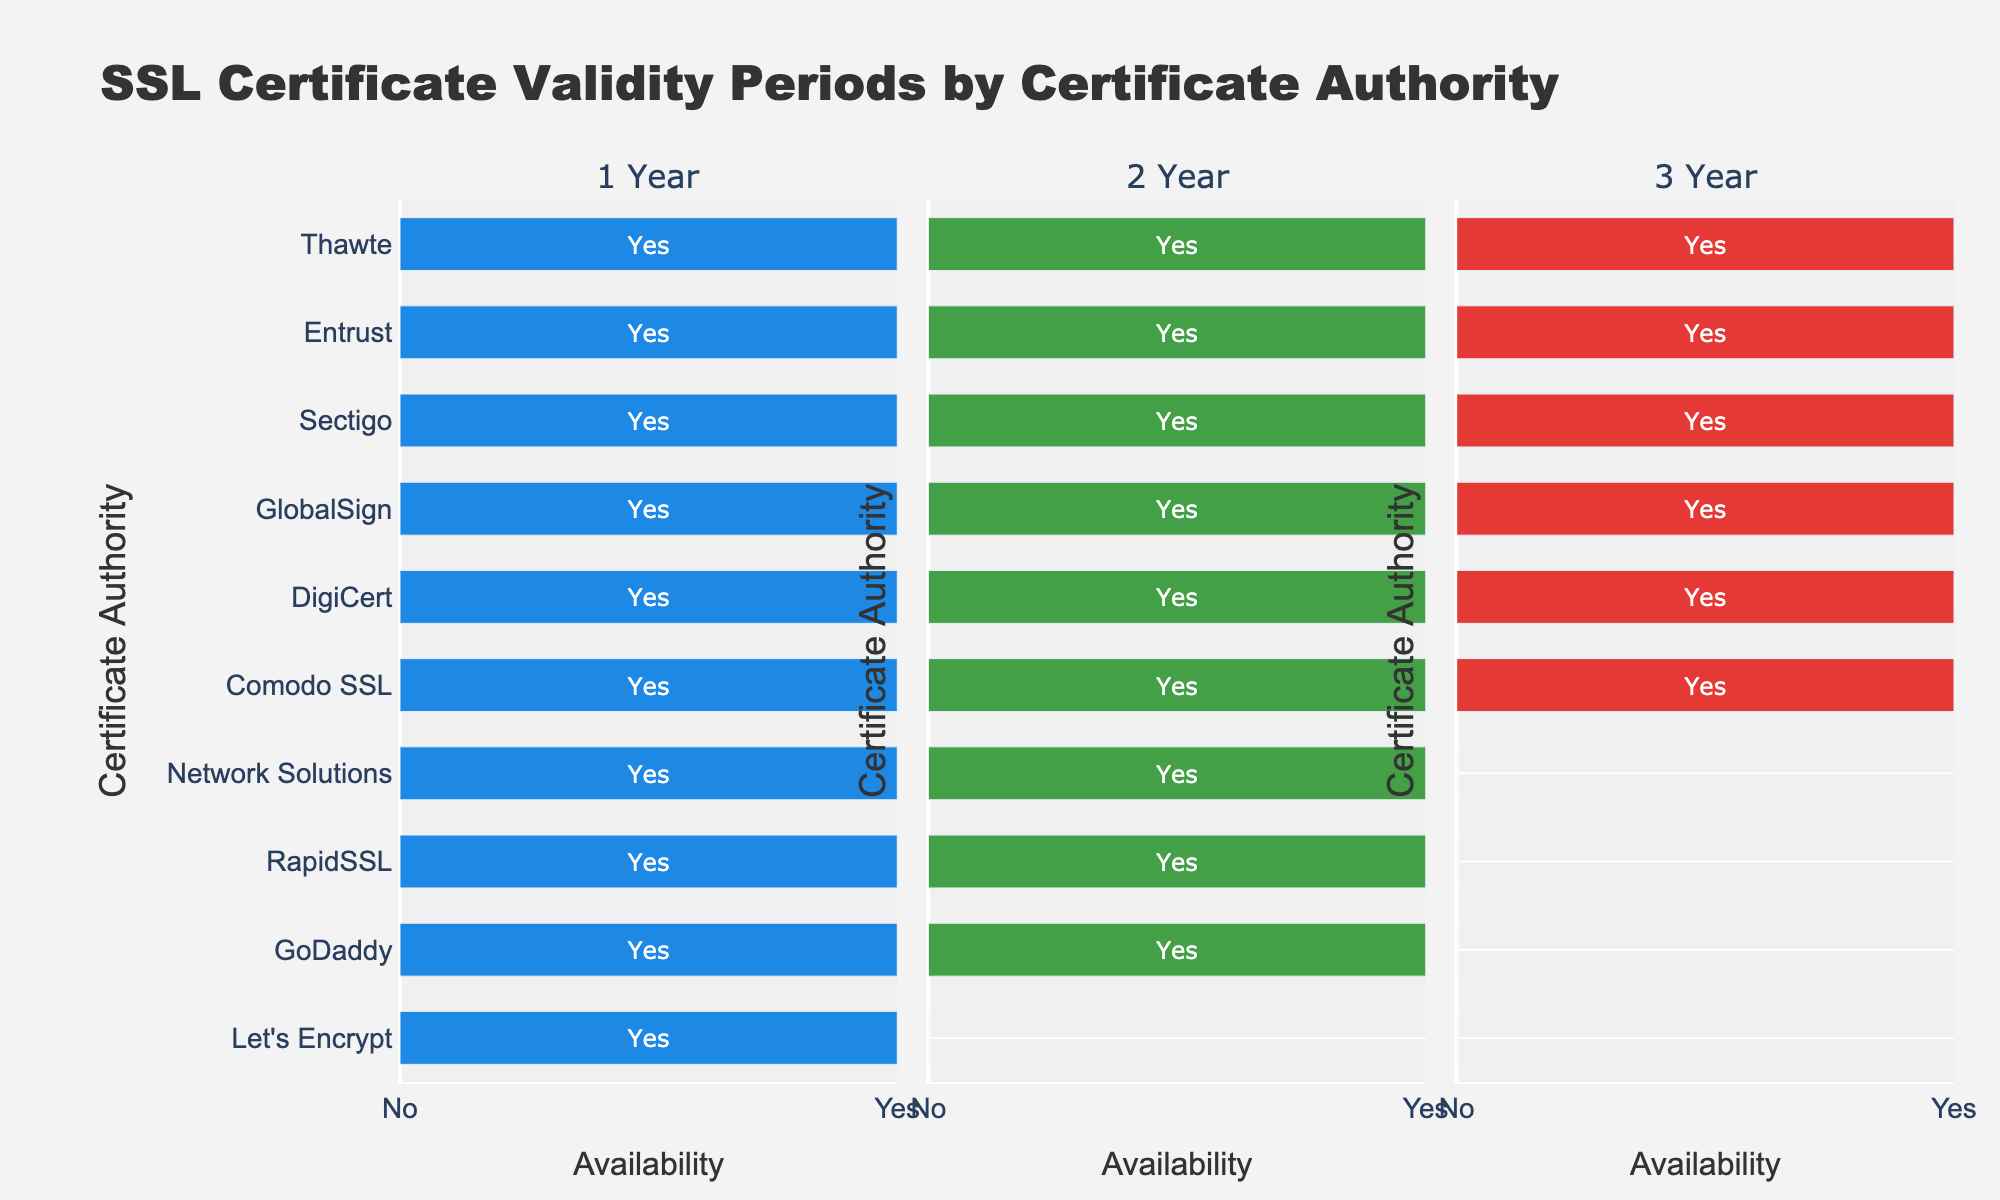What is the title of the figure? The title is found at the top of the figure, often in larger, bold font to stand out.
Answer: SSL Certificate Validity Periods by Certificate Authority Which Certificate Authorities offer 3-year SSL certificates? To find this, look at the bars in the third subplot labeled "3 Year". The bars that extend up to 'Yes' indicate availability of 3-year certificates.
Answer: Comodo SSL, DigiCert, GlobalSign, Sectigo, Entrust, Thawte How many Certificate Authorities offer 2-year SSL certificates? Check the second subplot labeled "2 Year" and count all the bars that extend to 'Yes', which indicates availability.
Answer: 9 Are there any Certificate Authorities that only offer 1-year SSL certificates? Look at the first subplot labeled "1 Year". Compare the other two subplots; if bars for 2 Year and 3 Year are at 'No' while 1 Year is 'Yes', then those are the CAs that only offer 1-year certificates.
Answer: Let's Encrypt Which Certificate Authority does not offer 3-year SSL certificates but offers 2-year SSL certificates? Compare the bars in the second and third subplots. Find a CA where the bar in "2 Year" extends to 'Yes', but in "3 Year" extends to 'No'.
Answer: GoDaddy, RapidSSL, Network Solutions Between Comodo SSL and GoDaddy, which offers a longer maximum SSL certificate duration? Compare the heights of the bars for Comodo SSL and GoDaddy in all three subplots. The one consistently reaching to 'Yes' for longer durations is the answer.
Answer: Comodo SSL How many Certificate Authorities offer SSL certificates for all three validity periods? Look at each Certificate Authority in all three subplots. Count how many of them have bars extending to 'Yes' in 1 Year, 2 Year, and 3 Year.
Answer: 5 Does Let's Encrypt offer SSL certificates longer than 1 year? Check the bars for Let's Encrypt in the 2 Year and 3 Year subplots. If the bars are at 'No', then they do not offer longer certificates.
Answer: No Which Certificate Authorities offer the most varied SSL certificate durations? Identify the CAs that have 'Yes' in the subplots for 1 Year, 2 Year, and 3 Year.
Answer: Comodo SSL, DigiCert, GlobalSign, Sectigo, Entrust, Thawte What is the unique color used for each validity period on the bar plots? The colors are reflected in the legend of the plot. Each period has a unique color distinguishing it from the others.
Answer: 1 Year is blue, 2 Year is green, 3 Year is red 